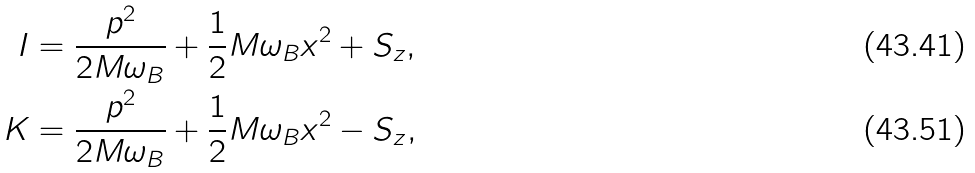<formula> <loc_0><loc_0><loc_500><loc_500>I & = \frac { p ^ { 2 } } { 2 M \omega _ { B } } + \frac { 1 } { 2 } M \omega _ { B } x ^ { 2 } + S _ { z } , \\ K & = \frac { p ^ { 2 } } { 2 M \omega _ { B } } + \frac { 1 } { 2 } M \omega _ { B } x ^ { 2 } - S _ { z } ,</formula> 